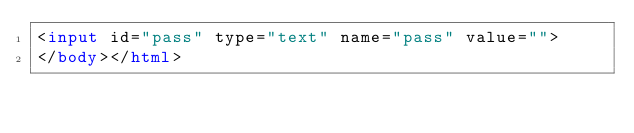<code> <loc_0><loc_0><loc_500><loc_500><_HTML_><input id="pass" type="text" name="pass" value="">
</body></html>
</code> 